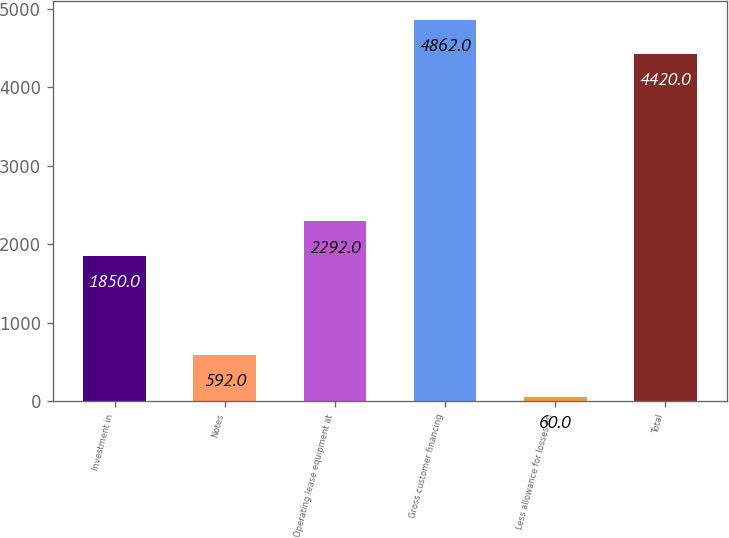<chart> <loc_0><loc_0><loc_500><loc_500><bar_chart><fcel>Investment in<fcel>Notes<fcel>Operating lease equipment at<fcel>Gross customer financing<fcel>Less allowance for losses on<fcel>Total<nl><fcel>1850<fcel>592<fcel>2292<fcel>4862<fcel>60<fcel>4420<nl></chart> 